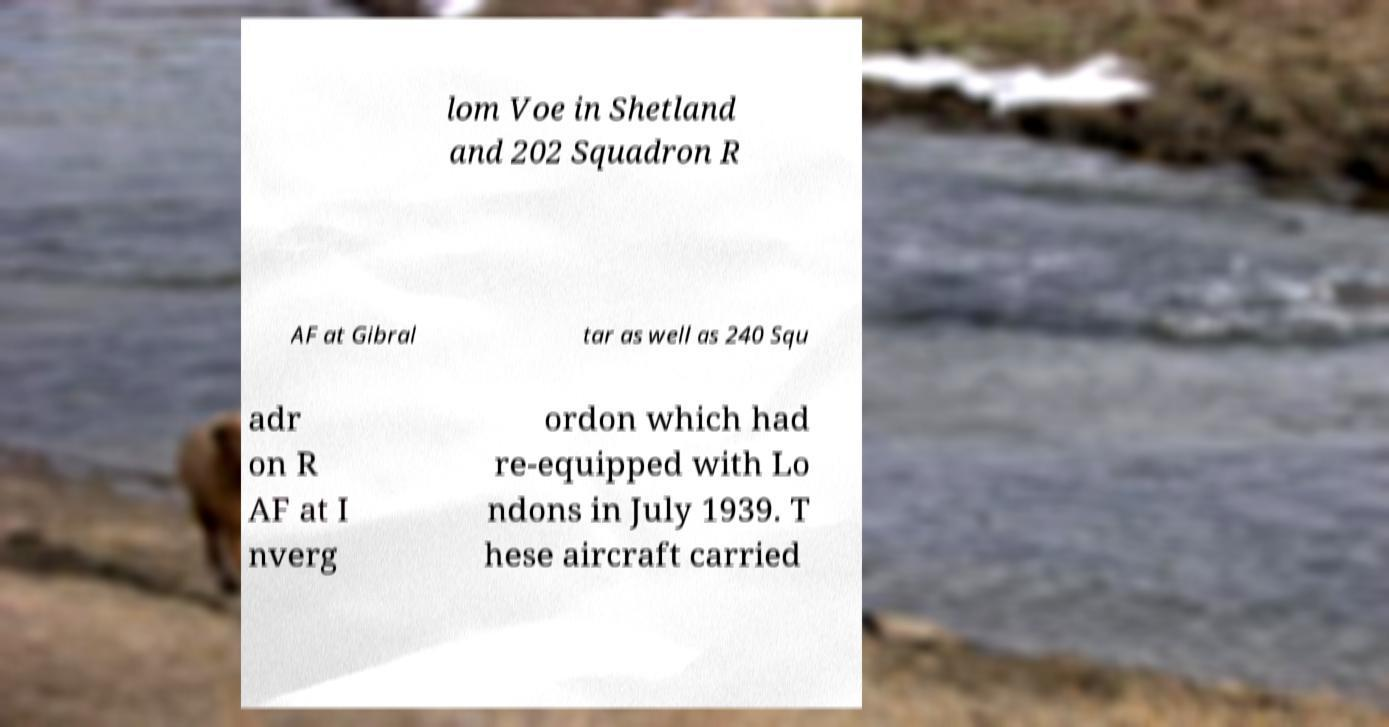Could you assist in decoding the text presented in this image and type it out clearly? lom Voe in Shetland and 202 Squadron R AF at Gibral tar as well as 240 Squ adr on R AF at I nverg ordon which had re-equipped with Lo ndons in July 1939. T hese aircraft carried 